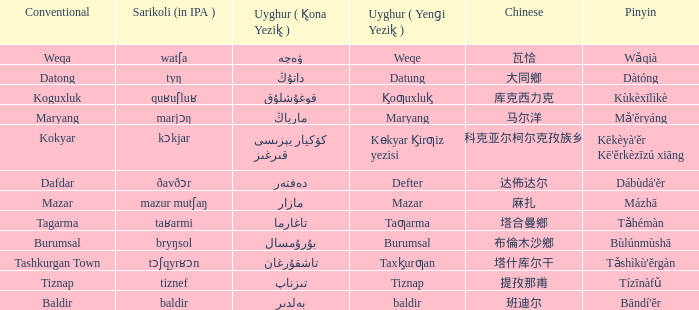Name the conventional for تاغارما Tagarma. 